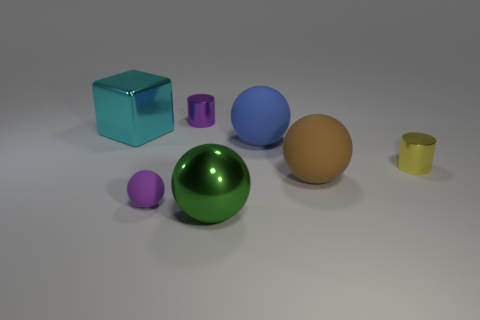Subtract all big balls. How many balls are left? 1 Subtract all purple spheres. How many spheres are left? 3 Add 2 big yellow blocks. How many objects exist? 9 Subtract 0 green blocks. How many objects are left? 7 Subtract all blocks. How many objects are left? 6 Subtract 2 spheres. How many spheres are left? 2 Subtract all brown spheres. Subtract all blue cubes. How many spheres are left? 3 Subtract all cyan spheres. How many purple cylinders are left? 1 Subtract all yellow objects. Subtract all small purple cylinders. How many objects are left? 5 Add 7 large cyan cubes. How many large cyan cubes are left? 8 